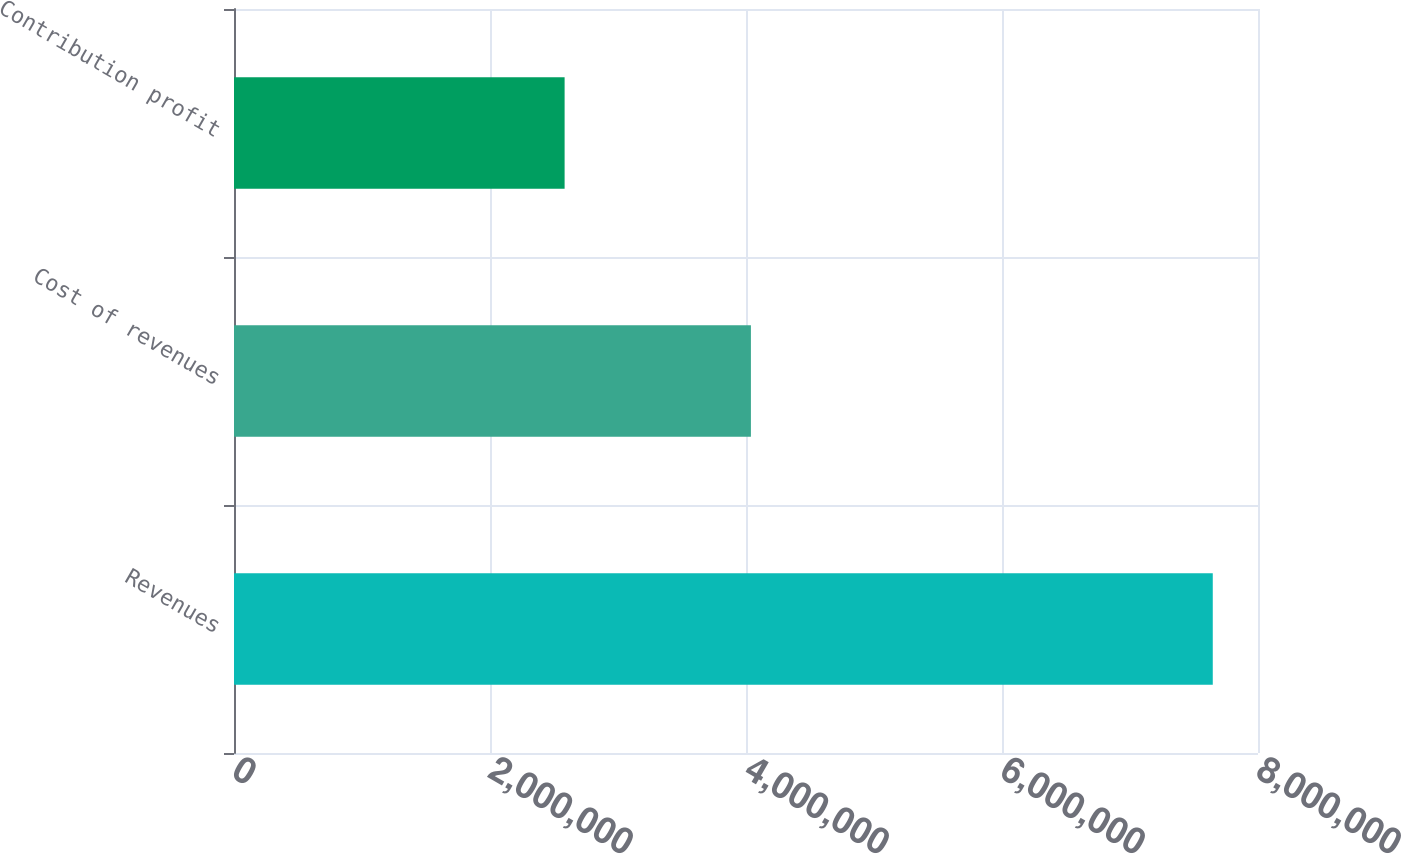<chart> <loc_0><loc_0><loc_500><loc_500><bar_chart><fcel>Revenues<fcel>Cost of revenues<fcel>Contribution profit<nl><fcel>7.64665e+06<fcel>4.03839e+06<fcel>2.5829e+06<nl></chart> 